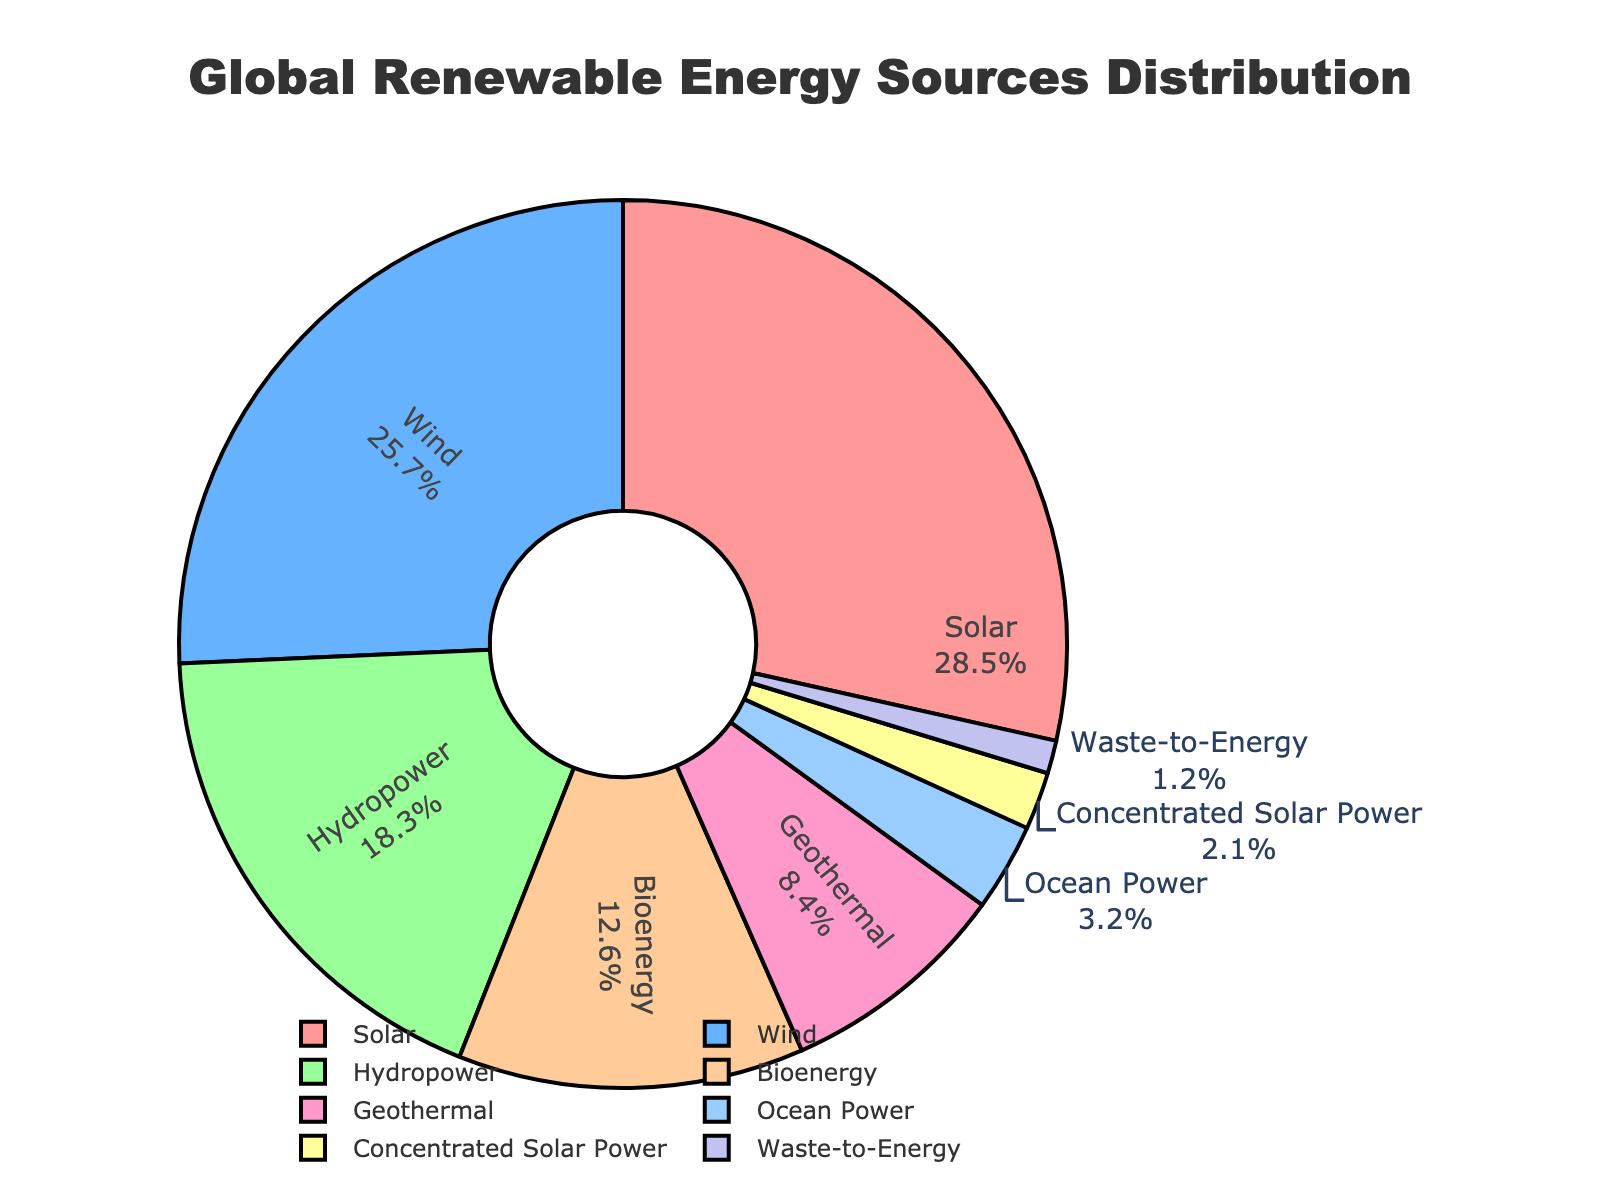Which renewable energy source has the highest percentage? The pie chart shows the distribution of different renewable energy sources. By looking at the slices, the largest one corresponds to Solar.
Answer: Solar Which energy source contributes the least to the global renewable energy mix? By examining the sizes of the slices in the pie chart, Waste-to-Energy has the smallest slice.
Answer: Waste-to-Energy How much higher in percentage is Solar compared to Wind? Solar has 28.5% and Wind has 25.7%. The difference is calculated as 28.5% - 25.7% = 2.8%.
Answer: 2.8% Is the combined percentage of Hydropower and Bioenergy more or less than half of the total distribution? Hydropower is 18.3% and Bioenergy is 12.6%. Summing these gives 18.3% + 12.6% = 30.9%, which is less than 50%.
Answer: Less What is the total percentage contributed by the three smallest sources? Waste-to-Energy (1.2%), Concentrated Solar Power (2.1%), and Ocean Power (3.2%) are the smallest. Their total is 1.2% + 2.1% + 3.2% = 6.5%.
Answer: 6.5% What is the combined contribution percentage of Solar and Wind energy? Solar contributes 28.5% and Wind contributes 25.7%. Adding these gives 28.5% + 25.7% = 54.2%.
Answer: 54.2% Which color is associated with Bioenergy in the pie chart? By observing the chart, we see that the color associated with Bioenergy is a light green shade.
Answer: Light Green Does Geothermal contribute more or less than 10% to the global renewable energy mix? The pie chart shows Geothermal at 8.4%, which is less than 10%.
Answer: Less By how much does the Hydropower contribution differ from Bioenergy? Hydropower contributes 18.3% and Bioenergy contributes 12.6%. The difference is 18.3% - 12.6% = 5.7%.
Answer: 5.7% What is the average contribution of Solar, Wind, and Geothermal energy? The percentages for Solar, Wind, and Geothermal are 28.5%, 25.7%, and 8.4%, respectively. Their sum is 28.5 + 25.7 + 8.4 = 62.6. The average is 62.6/3 ≈ 20.87%.
Answer: 20.87% 